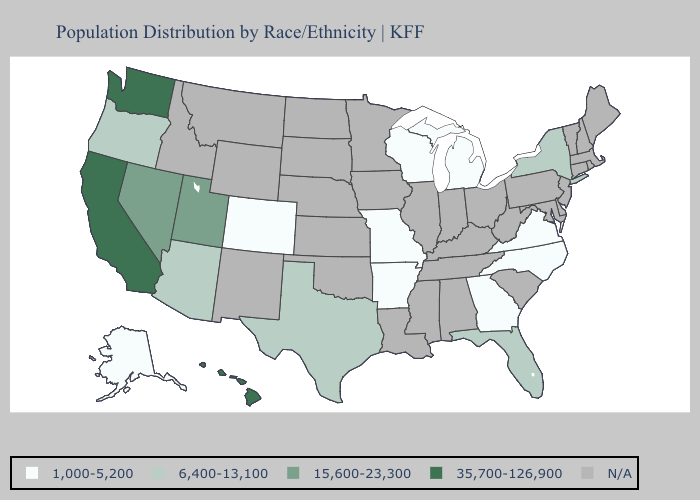Does the first symbol in the legend represent the smallest category?
Be succinct. Yes. Does Florida have the lowest value in the South?
Answer briefly. No. Name the states that have a value in the range 6,400-13,100?
Concise answer only. Arizona, Florida, New York, Oregon, Texas. Name the states that have a value in the range N/A?
Answer briefly. Alabama, Connecticut, Delaware, Idaho, Illinois, Indiana, Iowa, Kansas, Kentucky, Louisiana, Maine, Maryland, Massachusetts, Minnesota, Mississippi, Montana, Nebraska, New Hampshire, New Jersey, New Mexico, North Dakota, Ohio, Oklahoma, Pennsylvania, Rhode Island, South Carolina, South Dakota, Tennessee, Vermont, West Virginia, Wyoming. Does the map have missing data?
Concise answer only. Yes. Is the legend a continuous bar?
Short answer required. No. Does Washington have the highest value in the USA?
Keep it brief. Yes. What is the highest value in the USA?
Write a very short answer. 35,700-126,900. What is the value of Colorado?
Answer briefly. 1,000-5,200. Which states have the lowest value in the USA?
Answer briefly. Alaska, Arkansas, Colorado, Georgia, Michigan, Missouri, North Carolina, Virginia, Wisconsin. What is the value of Kansas?
Short answer required. N/A. What is the value of Louisiana?
Answer briefly. N/A. Name the states that have a value in the range 35,700-126,900?
Short answer required. California, Hawaii, Washington. 